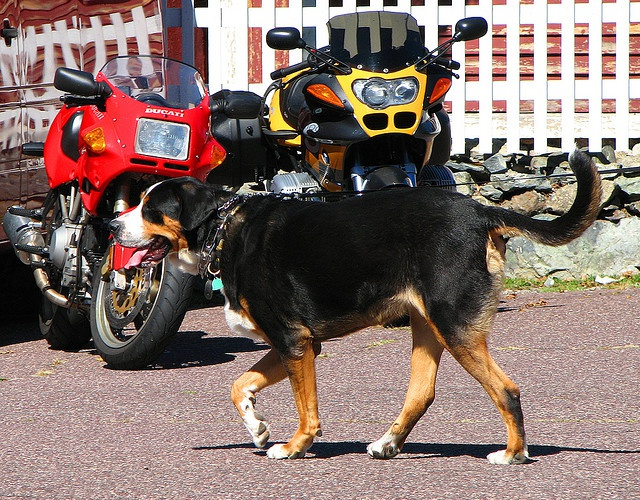Describe the objects in this image and their specific colors. I can see dog in maroon, black, gray, and orange tones, motorcycle in maroon, black, red, gray, and lightgray tones, and motorcycle in maroon, black, gray, white, and gold tones in this image. 